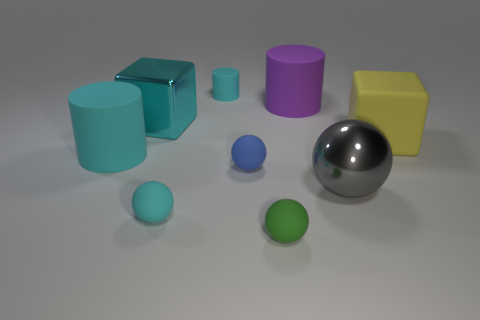There is a cyan matte object that is behind the big matte cylinder left of the tiny sphere to the right of the tiny blue thing; what is its shape?
Keep it short and to the point. Cylinder. There is a thing that is left of the gray thing and on the right side of the small green rubber thing; what size is it?
Offer a terse response. Large. What number of small spheres are the same color as the small cylinder?
Offer a very short reply. 1. There is a small ball that is the same color as the tiny matte cylinder; what material is it?
Make the answer very short. Rubber. What material is the large gray sphere?
Provide a succinct answer. Metal. Is the big block on the left side of the large purple matte cylinder made of the same material as the large purple thing?
Offer a terse response. No. What shape is the metal object in front of the yellow rubber object?
Ensure brevity in your answer.  Sphere. There is a ball that is the same size as the cyan metal thing; what is its material?
Your answer should be very brief. Metal. How many objects are either large matte objects on the left side of the small green rubber object or cyan rubber cylinders that are in front of the large cyan cube?
Make the answer very short. 1. The yellow object that is the same material as the green thing is what size?
Provide a short and direct response. Large. 